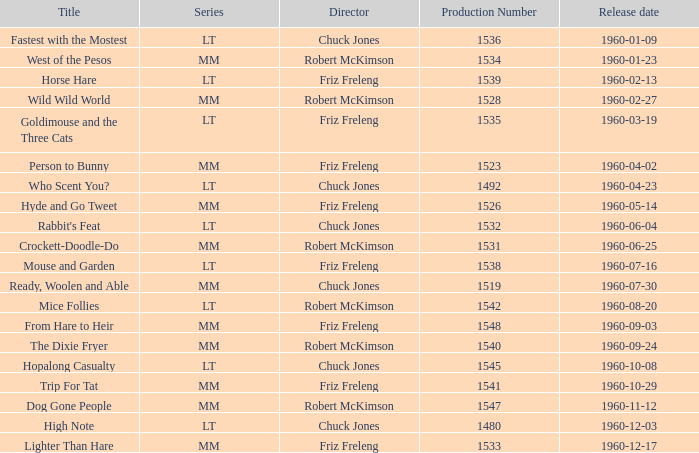What production number is assigned to the mice follies episode under robert mckimson's direction? 1.0. 